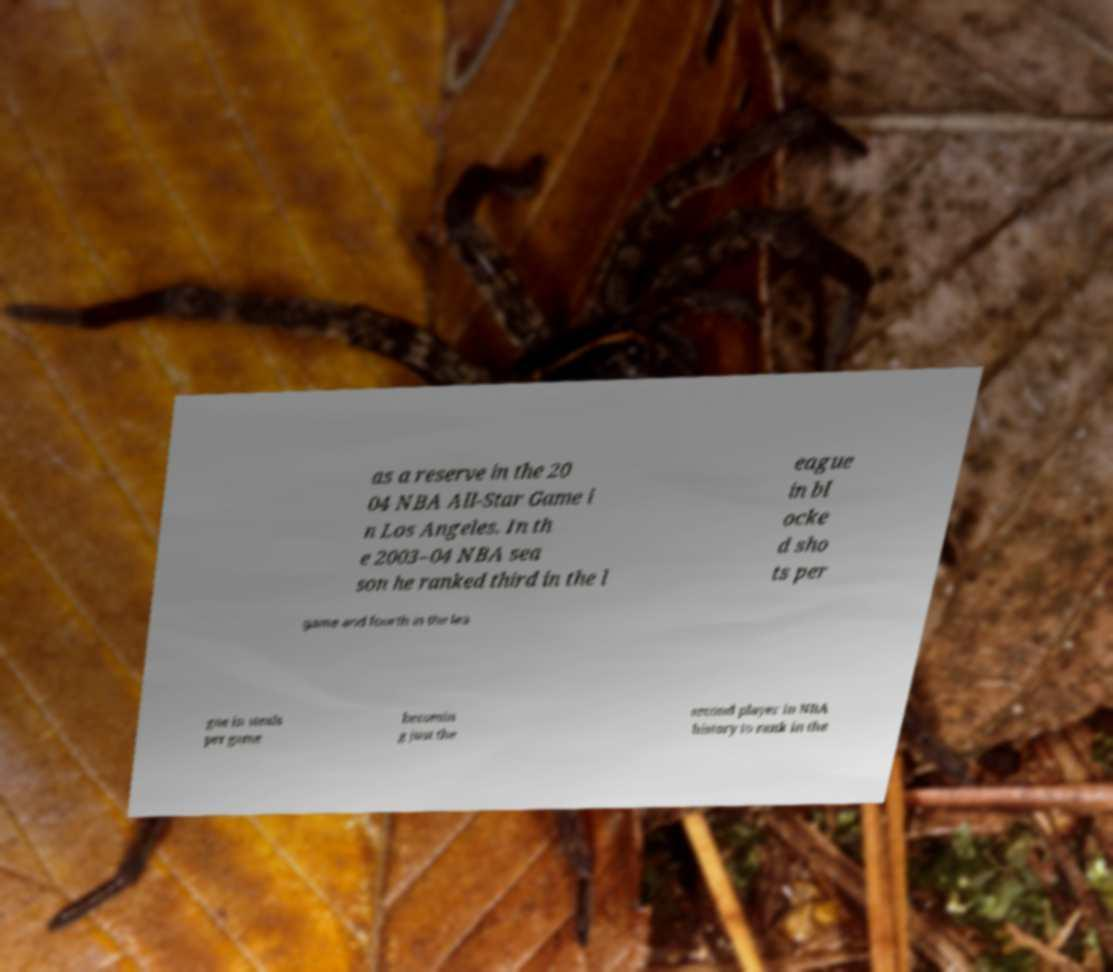Please identify and transcribe the text found in this image. as a reserve in the 20 04 NBA All-Star Game i n Los Angeles. In th e 2003–04 NBA sea son he ranked third in the l eague in bl ocke d sho ts per game and fourth in the lea gue in steals per game becomin g just the second player in NBA history to rank in the 